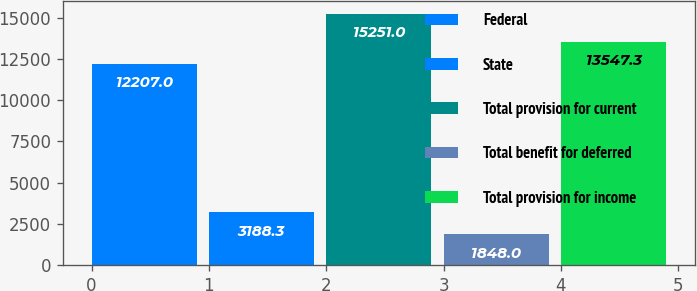Convert chart. <chart><loc_0><loc_0><loc_500><loc_500><bar_chart><fcel>Federal<fcel>State<fcel>Total provision for current<fcel>Total benefit for deferred<fcel>Total provision for income<nl><fcel>12207<fcel>3188.3<fcel>15251<fcel>1848<fcel>13547.3<nl></chart> 